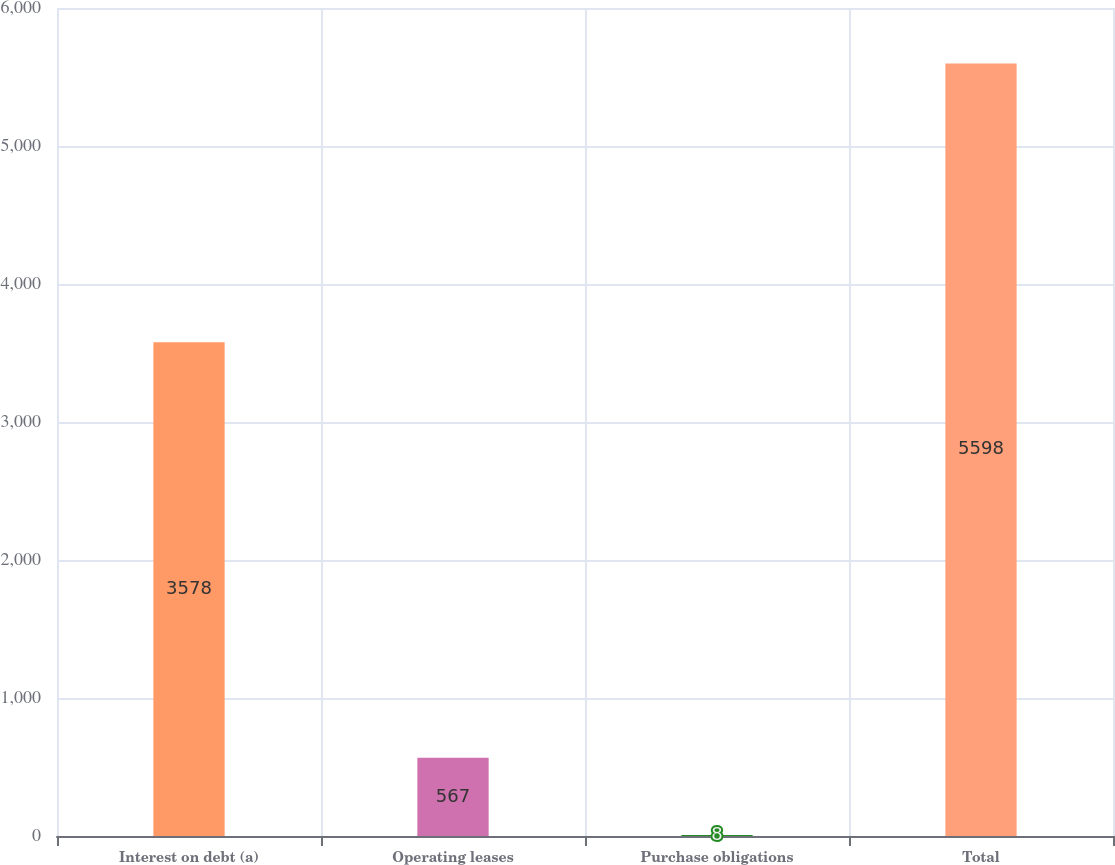Convert chart to OTSL. <chart><loc_0><loc_0><loc_500><loc_500><bar_chart><fcel>Interest on debt (a)<fcel>Operating leases<fcel>Purchase obligations<fcel>Total<nl><fcel>3578<fcel>567<fcel>8<fcel>5598<nl></chart> 